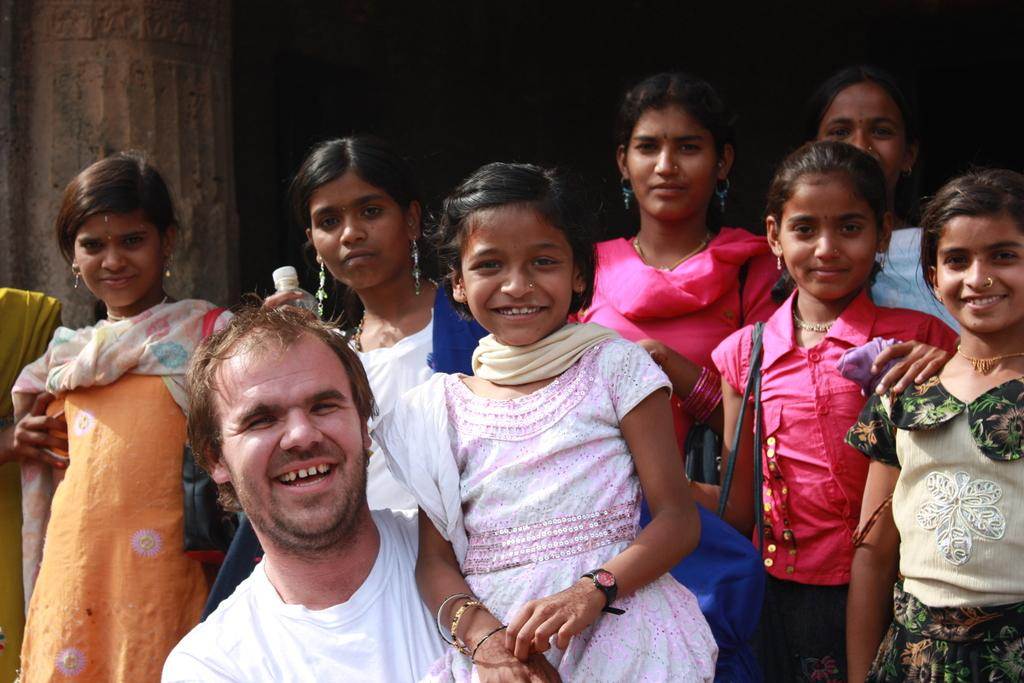Who or what is present in the image? There are people in the image. What is the mood or expression of the people in the image? The people are smiling in the image. What object can be seen in addition to the people? There is a bottle visible in the image. What else can be seen in the image besides the people and the bottle? There are bags in the image. What type of fruit is being used in the fight depicted in the image? There is no fight or fruit present in the image; it features people smiling with a bottle and bags. 